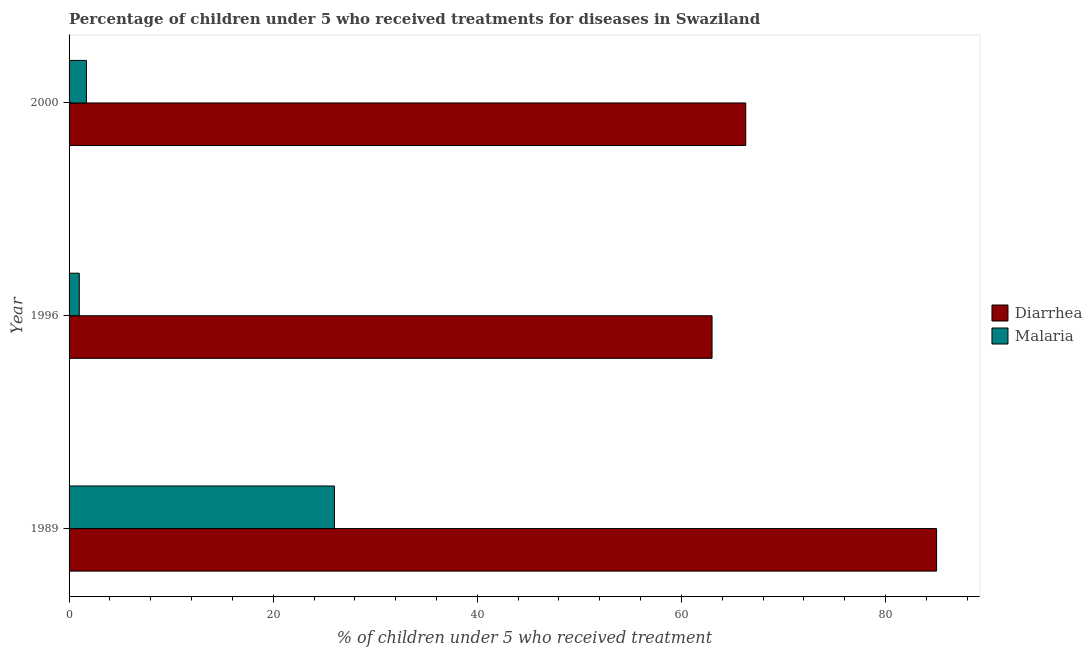Are the number of bars per tick equal to the number of legend labels?
Provide a short and direct response. Yes. Are the number of bars on each tick of the Y-axis equal?
Give a very brief answer. Yes. How many bars are there on the 2nd tick from the top?
Your answer should be compact. 2. How many bars are there on the 3rd tick from the bottom?
Ensure brevity in your answer.  2. In how many cases, is the number of bars for a given year not equal to the number of legend labels?
Ensure brevity in your answer.  0. What is the percentage of children who received treatment for malaria in 1996?
Keep it short and to the point. 1. Across all years, what is the maximum percentage of children who received treatment for diarrhoea?
Provide a short and direct response. 85. Across all years, what is the minimum percentage of children who received treatment for malaria?
Offer a very short reply. 1. In which year was the percentage of children who received treatment for diarrhoea maximum?
Offer a terse response. 1989. What is the total percentage of children who received treatment for diarrhoea in the graph?
Your answer should be compact. 214.3. What is the difference between the percentage of children who received treatment for malaria in 2000 and the percentage of children who received treatment for diarrhoea in 1996?
Keep it short and to the point. -61.3. What is the average percentage of children who received treatment for diarrhoea per year?
Offer a terse response. 71.43. In the year 2000, what is the difference between the percentage of children who received treatment for diarrhoea and percentage of children who received treatment for malaria?
Provide a succinct answer. 64.6. What is the ratio of the percentage of children who received treatment for diarrhoea in 1989 to that in 2000?
Make the answer very short. 1.28. Is the difference between the percentage of children who received treatment for diarrhoea in 1996 and 2000 greater than the difference between the percentage of children who received treatment for malaria in 1996 and 2000?
Keep it short and to the point. No. In how many years, is the percentage of children who received treatment for diarrhoea greater than the average percentage of children who received treatment for diarrhoea taken over all years?
Make the answer very short. 1. What does the 1st bar from the top in 1989 represents?
Give a very brief answer. Malaria. What does the 1st bar from the bottom in 1989 represents?
Ensure brevity in your answer.  Diarrhea. How many bars are there?
Your response must be concise. 6. Are all the bars in the graph horizontal?
Offer a terse response. Yes. How many years are there in the graph?
Provide a succinct answer. 3. Are the values on the major ticks of X-axis written in scientific E-notation?
Give a very brief answer. No. Does the graph contain grids?
Your response must be concise. No. Where does the legend appear in the graph?
Give a very brief answer. Center right. How many legend labels are there?
Give a very brief answer. 2. How are the legend labels stacked?
Your response must be concise. Vertical. What is the title of the graph?
Offer a terse response. Percentage of children under 5 who received treatments for diseases in Swaziland. Does "Malaria" appear as one of the legend labels in the graph?
Your response must be concise. Yes. What is the label or title of the X-axis?
Your answer should be very brief. % of children under 5 who received treatment. What is the % of children under 5 who received treatment of Malaria in 1989?
Provide a succinct answer. 26. What is the % of children under 5 who received treatment in Diarrhea in 1996?
Make the answer very short. 63. What is the % of children under 5 who received treatment in Malaria in 1996?
Your answer should be compact. 1. What is the % of children under 5 who received treatment in Diarrhea in 2000?
Your response must be concise. 66.3. What is the % of children under 5 who received treatment of Malaria in 2000?
Your answer should be very brief. 1.7. Across all years, what is the maximum % of children under 5 who received treatment of Diarrhea?
Your response must be concise. 85. Across all years, what is the minimum % of children under 5 who received treatment in Diarrhea?
Give a very brief answer. 63. What is the total % of children under 5 who received treatment in Diarrhea in the graph?
Offer a very short reply. 214.3. What is the total % of children under 5 who received treatment in Malaria in the graph?
Your answer should be very brief. 28.7. What is the difference between the % of children under 5 who received treatment of Diarrhea in 1989 and that in 2000?
Provide a succinct answer. 18.7. What is the difference between the % of children under 5 who received treatment in Malaria in 1989 and that in 2000?
Provide a short and direct response. 24.3. What is the difference between the % of children under 5 who received treatment in Diarrhea in 1996 and that in 2000?
Make the answer very short. -3.3. What is the difference between the % of children under 5 who received treatment in Malaria in 1996 and that in 2000?
Ensure brevity in your answer.  -0.7. What is the difference between the % of children under 5 who received treatment in Diarrhea in 1989 and the % of children under 5 who received treatment in Malaria in 2000?
Provide a succinct answer. 83.3. What is the difference between the % of children under 5 who received treatment in Diarrhea in 1996 and the % of children under 5 who received treatment in Malaria in 2000?
Your answer should be very brief. 61.3. What is the average % of children under 5 who received treatment in Diarrhea per year?
Provide a short and direct response. 71.43. What is the average % of children under 5 who received treatment of Malaria per year?
Keep it short and to the point. 9.57. In the year 1996, what is the difference between the % of children under 5 who received treatment of Diarrhea and % of children under 5 who received treatment of Malaria?
Make the answer very short. 62. In the year 2000, what is the difference between the % of children under 5 who received treatment of Diarrhea and % of children under 5 who received treatment of Malaria?
Your answer should be very brief. 64.6. What is the ratio of the % of children under 5 who received treatment of Diarrhea in 1989 to that in 1996?
Ensure brevity in your answer.  1.35. What is the ratio of the % of children under 5 who received treatment in Malaria in 1989 to that in 1996?
Your answer should be compact. 26. What is the ratio of the % of children under 5 who received treatment in Diarrhea in 1989 to that in 2000?
Ensure brevity in your answer.  1.28. What is the ratio of the % of children under 5 who received treatment in Malaria in 1989 to that in 2000?
Your answer should be very brief. 15.29. What is the ratio of the % of children under 5 who received treatment of Diarrhea in 1996 to that in 2000?
Offer a terse response. 0.95. What is the ratio of the % of children under 5 who received treatment in Malaria in 1996 to that in 2000?
Provide a succinct answer. 0.59. What is the difference between the highest and the second highest % of children under 5 who received treatment of Diarrhea?
Give a very brief answer. 18.7. What is the difference between the highest and the second highest % of children under 5 who received treatment of Malaria?
Provide a short and direct response. 24.3. 